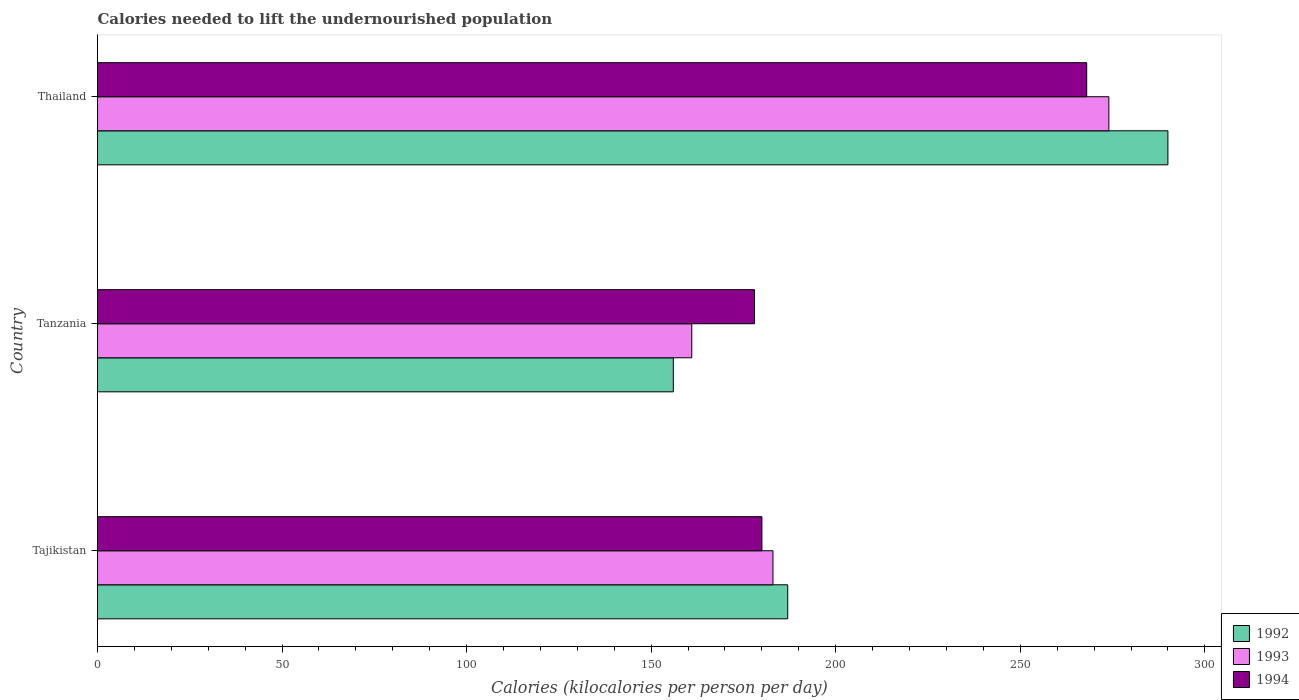Are the number of bars per tick equal to the number of legend labels?
Make the answer very short. Yes. How many bars are there on the 1st tick from the top?
Your answer should be compact. 3. How many bars are there on the 3rd tick from the bottom?
Give a very brief answer. 3. What is the label of the 3rd group of bars from the top?
Your answer should be very brief. Tajikistan. In how many cases, is the number of bars for a given country not equal to the number of legend labels?
Your response must be concise. 0. What is the total calories needed to lift the undernourished population in 1993 in Tajikistan?
Offer a terse response. 183. Across all countries, what is the maximum total calories needed to lift the undernourished population in 1992?
Your answer should be compact. 290. Across all countries, what is the minimum total calories needed to lift the undernourished population in 1994?
Ensure brevity in your answer.  178. In which country was the total calories needed to lift the undernourished population in 1992 maximum?
Offer a terse response. Thailand. In which country was the total calories needed to lift the undernourished population in 1993 minimum?
Your response must be concise. Tanzania. What is the total total calories needed to lift the undernourished population in 1992 in the graph?
Ensure brevity in your answer.  633. What is the difference between the total calories needed to lift the undernourished population in 1992 in Tanzania and that in Thailand?
Make the answer very short. -134. What is the difference between the total calories needed to lift the undernourished population in 1993 in Thailand and the total calories needed to lift the undernourished population in 1994 in Tanzania?
Provide a succinct answer. 96. What is the average total calories needed to lift the undernourished population in 1992 per country?
Provide a succinct answer. 211. What is the difference between the total calories needed to lift the undernourished population in 1994 and total calories needed to lift the undernourished population in 1992 in Tanzania?
Offer a very short reply. 22. In how many countries, is the total calories needed to lift the undernourished population in 1994 greater than 240 kilocalories?
Offer a terse response. 1. What is the ratio of the total calories needed to lift the undernourished population in 1993 in Tajikistan to that in Tanzania?
Offer a very short reply. 1.14. Is the total calories needed to lift the undernourished population in 1992 in Tajikistan less than that in Thailand?
Provide a short and direct response. Yes. What is the difference between the highest and the second highest total calories needed to lift the undernourished population in 1992?
Your response must be concise. 103. What is the difference between the highest and the lowest total calories needed to lift the undernourished population in 1994?
Provide a succinct answer. 90. Is the sum of the total calories needed to lift the undernourished population in 1992 in Tajikistan and Thailand greater than the maximum total calories needed to lift the undernourished population in 1994 across all countries?
Your answer should be compact. Yes. What does the 3rd bar from the bottom in Tajikistan represents?
Give a very brief answer. 1994. Are all the bars in the graph horizontal?
Offer a very short reply. Yes. Does the graph contain any zero values?
Make the answer very short. No. Does the graph contain grids?
Your answer should be very brief. No. What is the title of the graph?
Your response must be concise. Calories needed to lift the undernourished population. Does "1988" appear as one of the legend labels in the graph?
Your answer should be very brief. No. What is the label or title of the X-axis?
Offer a very short reply. Calories (kilocalories per person per day). What is the Calories (kilocalories per person per day) of 1992 in Tajikistan?
Offer a very short reply. 187. What is the Calories (kilocalories per person per day) of 1993 in Tajikistan?
Keep it short and to the point. 183. What is the Calories (kilocalories per person per day) in 1994 in Tajikistan?
Your response must be concise. 180. What is the Calories (kilocalories per person per day) in 1992 in Tanzania?
Your answer should be very brief. 156. What is the Calories (kilocalories per person per day) of 1993 in Tanzania?
Keep it short and to the point. 161. What is the Calories (kilocalories per person per day) in 1994 in Tanzania?
Give a very brief answer. 178. What is the Calories (kilocalories per person per day) of 1992 in Thailand?
Ensure brevity in your answer.  290. What is the Calories (kilocalories per person per day) in 1993 in Thailand?
Ensure brevity in your answer.  274. What is the Calories (kilocalories per person per day) in 1994 in Thailand?
Provide a short and direct response. 268. Across all countries, what is the maximum Calories (kilocalories per person per day) in 1992?
Offer a terse response. 290. Across all countries, what is the maximum Calories (kilocalories per person per day) of 1993?
Offer a very short reply. 274. Across all countries, what is the maximum Calories (kilocalories per person per day) of 1994?
Offer a very short reply. 268. Across all countries, what is the minimum Calories (kilocalories per person per day) in 1992?
Your answer should be very brief. 156. Across all countries, what is the minimum Calories (kilocalories per person per day) of 1993?
Keep it short and to the point. 161. Across all countries, what is the minimum Calories (kilocalories per person per day) in 1994?
Give a very brief answer. 178. What is the total Calories (kilocalories per person per day) of 1992 in the graph?
Provide a short and direct response. 633. What is the total Calories (kilocalories per person per day) in 1993 in the graph?
Provide a succinct answer. 618. What is the total Calories (kilocalories per person per day) in 1994 in the graph?
Make the answer very short. 626. What is the difference between the Calories (kilocalories per person per day) in 1993 in Tajikistan and that in Tanzania?
Your answer should be compact. 22. What is the difference between the Calories (kilocalories per person per day) in 1992 in Tajikistan and that in Thailand?
Your answer should be very brief. -103. What is the difference between the Calories (kilocalories per person per day) in 1993 in Tajikistan and that in Thailand?
Keep it short and to the point. -91. What is the difference between the Calories (kilocalories per person per day) of 1994 in Tajikistan and that in Thailand?
Make the answer very short. -88. What is the difference between the Calories (kilocalories per person per day) in 1992 in Tanzania and that in Thailand?
Ensure brevity in your answer.  -134. What is the difference between the Calories (kilocalories per person per day) of 1993 in Tanzania and that in Thailand?
Provide a succinct answer. -113. What is the difference between the Calories (kilocalories per person per day) in 1994 in Tanzania and that in Thailand?
Your answer should be compact. -90. What is the difference between the Calories (kilocalories per person per day) of 1992 in Tajikistan and the Calories (kilocalories per person per day) of 1993 in Tanzania?
Give a very brief answer. 26. What is the difference between the Calories (kilocalories per person per day) in 1993 in Tajikistan and the Calories (kilocalories per person per day) in 1994 in Tanzania?
Your answer should be very brief. 5. What is the difference between the Calories (kilocalories per person per day) in 1992 in Tajikistan and the Calories (kilocalories per person per day) in 1993 in Thailand?
Your answer should be very brief. -87. What is the difference between the Calories (kilocalories per person per day) in 1992 in Tajikistan and the Calories (kilocalories per person per day) in 1994 in Thailand?
Your response must be concise. -81. What is the difference between the Calories (kilocalories per person per day) in 1993 in Tajikistan and the Calories (kilocalories per person per day) in 1994 in Thailand?
Your answer should be compact. -85. What is the difference between the Calories (kilocalories per person per day) in 1992 in Tanzania and the Calories (kilocalories per person per day) in 1993 in Thailand?
Give a very brief answer. -118. What is the difference between the Calories (kilocalories per person per day) in 1992 in Tanzania and the Calories (kilocalories per person per day) in 1994 in Thailand?
Ensure brevity in your answer.  -112. What is the difference between the Calories (kilocalories per person per day) in 1993 in Tanzania and the Calories (kilocalories per person per day) in 1994 in Thailand?
Offer a very short reply. -107. What is the average Calories (kilocalories per person per day) in 1992 per country?
Your answer should be very brief. 211. What is the average Calories (kilocalories per person per day) in 1993 per country?
Offer a terse response. 206. What is the average Calories (kilocalories per person per day) in 1994 per country?
Keep it short and to the point. 208.67. What is the difference between the Calories (kilocalories per person per day) in 1992 and Calories (kilocalories per person per day) in 1993 in Tajikistan?
Your response must be concise. 4. What is the difference between the Calories (kilocalories per person per day) of 1992 and Calories (kilocalories per person per day) of 1994 in Tajikistan?
Give a very brief answer. 7. What is the difference between the Calories (kilocalories per person per day) in 1993 and Calories (kilocalories per person per day) in 1994 in Tajikistan?
Your answer should be very brief. 3. What is the difference between the Calories (kilocalories per person per day) of 1992 and Calories (kilocalories per person per day) of 1994 in Tanzania?
Ensure brevity in your answer.  -22. What is the difference between the Calories (kilocalories per person per day) of 1993 and Calories (kilocalories per person per day) of 1994 in Tanzania?
Offer a terse response. -17. What is the ratio of the Calories (kilocalories per person per day) in 1992 in Tajikistan to that in Tanzania?
Offer a very short reply. 1.2. What is the ratio of the Calories (kilocalories per person per day) in 1993 in Tajikistan to that in Tanzania?
Offer a terse response. 1.14. What is the ratio of the Calories (kilocalories per person per day) of 1994 in Tajikistan to that in Tanzania?
Offer a terse response. 1.01. What is the ratio of the Calories (kilocalories per person per day) of 1992 in Tajikistan to that in Thailand?
Your response must be concise. 0.64. What is the ratio of the Calories (kilocalories per person per day) of 1993 in Tajikistan to that in Thailand?
Offer a terse response. 0.67. What is the ratio of the Calories (kilocalories per person per day) in 1994 in Tajikistan to that in Thailand?
Ensure brevity in your answer.  0.67. What is the ratio of the Calories (kilocalories per person per day) of 1992 in Tanzania to that in Thailand?
Provide a succinct answer. 0.54. What is the ratio of the Calories (kilocalories per person per day) of 1993 in Tanzania to that in Thailand?
Your answer should be very brief. 0.59. What is the ratio of the Calories (kilocalories per person per day) of 1994 in Tanzania to that in Thailand?
Provide a short and direct response. 0.66. What is the difference between the highest and the second highest Calories (kilocalories per person per day) of 1992?
Offer a terse response. 103. What is the difference between the highest and the second highest Calories (kilocalories per person per day) in 1993?
Offer a terse response. 91. What is the difference between the highest and the lowest Calories (kilocalories per person per day) of 1992?
Your answer should be compact. 134. What is the difference between the highest and the lowest Calories (kilocalories per person per day) in 1993?
Provide a short and direct response. 113. What is the difference between the highest and the lowest Calories (kilocalories per person per day) of 1994?
Ensure brevity in your answer.  90. 